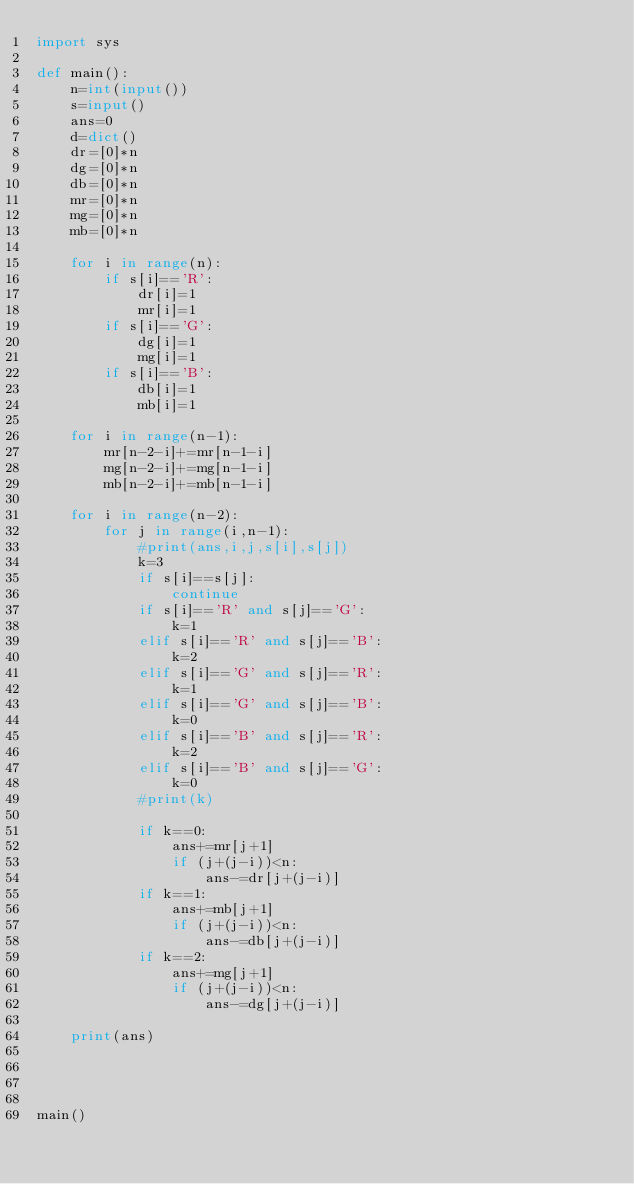<code> <loc_0><loc_0><loc_500><loc_500><_Python_>import sys

def main():
    n=int(input())
    s=input()
    ans=0
    d=dict()
    dr=[0]*n
    dg=[0]*n
    db=[0]*n
    mr=[0]*n
    mg=[0]*n
    mb=[0]*n

    for i in range(n):
        if s[i]=='R':
            dr[i]=1
            mr[i]=1
        if s[i]=='G':
            dg[i]=1
            mg[i]=1
        if s[i]=='B':
            db[i]=1
            mb[i]=1

    for i in range(n-1):
        mr[n-2-i]+=mr[n-1-i]
        mg[n-2-i]+=mg[n-1-i]
        mb[n-2-i]+=mb[n-1-i]

    for i in range(n-2):
        for j in range(i,n-1):
            #print(ans,i,j,s[i],s[j])
            k=3
            if s[i]==s[j]:
                continue
            if s[i]=='R' and s[j]=='G':
                k=1
            elif s[i]=='R' and s[j]=='B':
                k=2
            elif s[i]=='G' and s[j]=='R':
                k=1
            elif s[i]=='G' and s[j]=='B':
                k=0
            elif s[i]=='B' and s[j]=='R':
                k=2
            elif s[i]=='B' and s[j]=='G':
                k=0
            #print(k)
            
            if k==0:
                ans+=mr[j+1]
                if (j+(j-i))<n:
                    ans-=dr[j+(j-i)]
            if k==1:
                ans+=mb[j+1]
                if (j+(j-i))<n:
                    ans-=db[j+(j-i)]
            if k==2:
                ans+=mg[j+1]
                if (j+(j-i))<n:
                    ans-=dg[j+(j-i)]

    print(ans)
        



main()</code> 